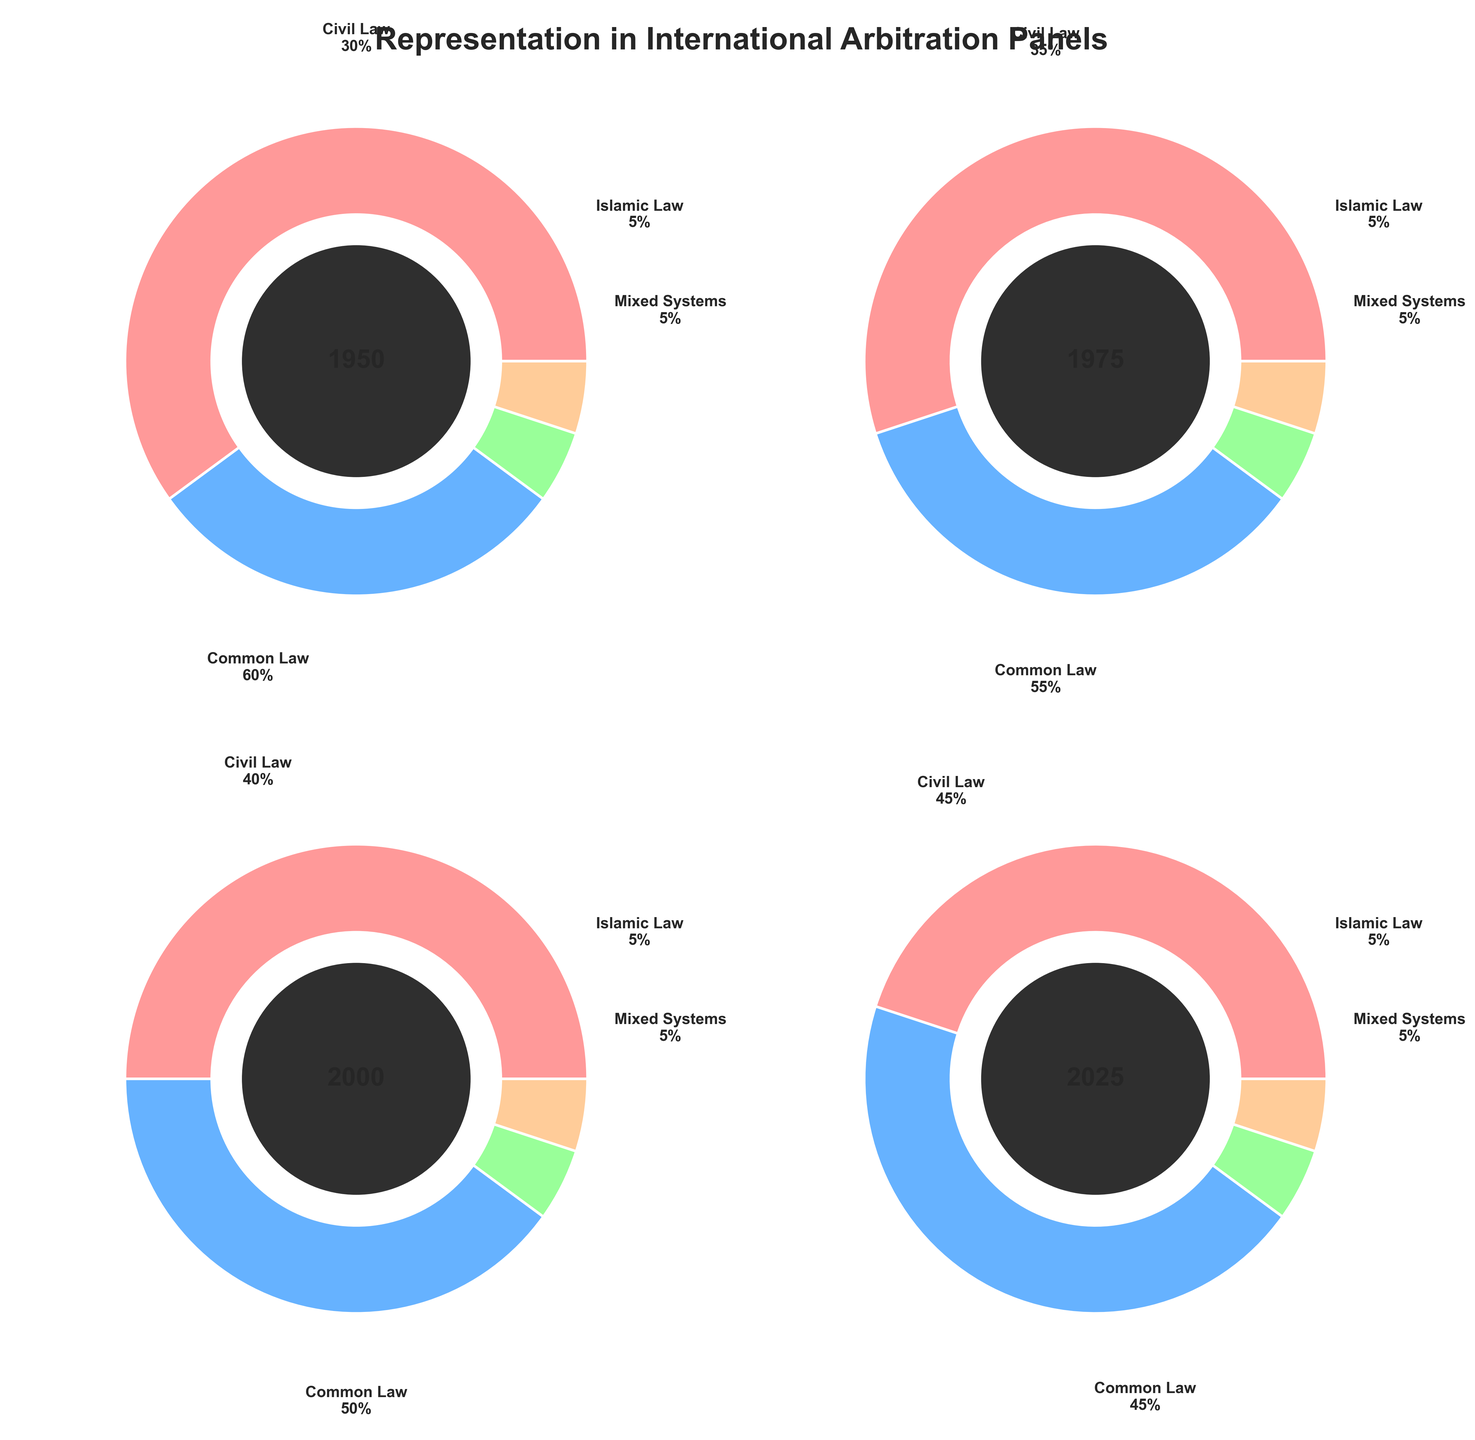What's the title of the figure? The title is clearly displayed at the top of the figure. It reads "Representation in International Arbitration Panels." This can be directly observed at the top center.
Answer: Representation in International Arbitration Panels What are the four categories of legal systems represented in the figure? Each panel of the gauge charts has labels indicating the legal systems. They are "Common Law," "Civil Law," "Islamic Law," and "Mixed Systems." These categories are consistently labeled across all subplots.
Answer: Common Law, Civil Law, Islamic Law, Mixed Systems In which year is the representation of Common Law the highest? By looking at the four gauges, the representation of Common Law is depicted at 60% in the year 1950, which is the highest among the other years presented.
Answer: 1950 How does the representation of Civil Law change from 1950 to 2025? Starting from 30% in 1950, Civil Law representation gradually increases to 35% in 1975, 40% in 2000, and finally reaches 45% in 2025.
Answer: Increases from 30% to 45% What is the combined representation of Common Law and Civil Law in 2000? In the 2000 gauge chart, Common Law is at 50% and Civil Law at 40%. Adding these gives us a combined representation of 50% + 40% = 90%.
Answer: 90% Which year shows the most balanced representation of the legal systems? By examining the angles and values across the years, in 2025 the representation is 45% for Common Law, 45% for Civil Law, 5% for Islamic Law, and 5% for Mixed Systems, which appears the most balanced.
Answer: 2025 How much did the representation of Islamic Law change over the years? From 1950 to 2025, the representation of Islamic Law remains constant at 5% in each year. So, there was no change in the representation of Islamic Law.
Answer: No change Compare the total representation of Mixed Systems in 1950 and 2025. How much did it change? Both in 1950 and 2025, Mixed Systems representation is 5%. Hence, the change in their representation is 5% - 5% = 0%.
Answer: No change What is the average representation of Common Law over the years shown in the figure? The representations are 60% (1950), 55% (1975), 50% (2000), and 45% (2025). To find the average: (60 + 55 + 50 + 45) / 4 = 210 / 4 = 52.5%.
Answer: 52.5% In 1975, which legal system has the second highest representation? In the 1975 gauge chart, Common Law is the highest at 55%, and Civil Law comes second at 35%. This can be identified by comparing the segment sizes in the chart.
Answer: Civil Law 